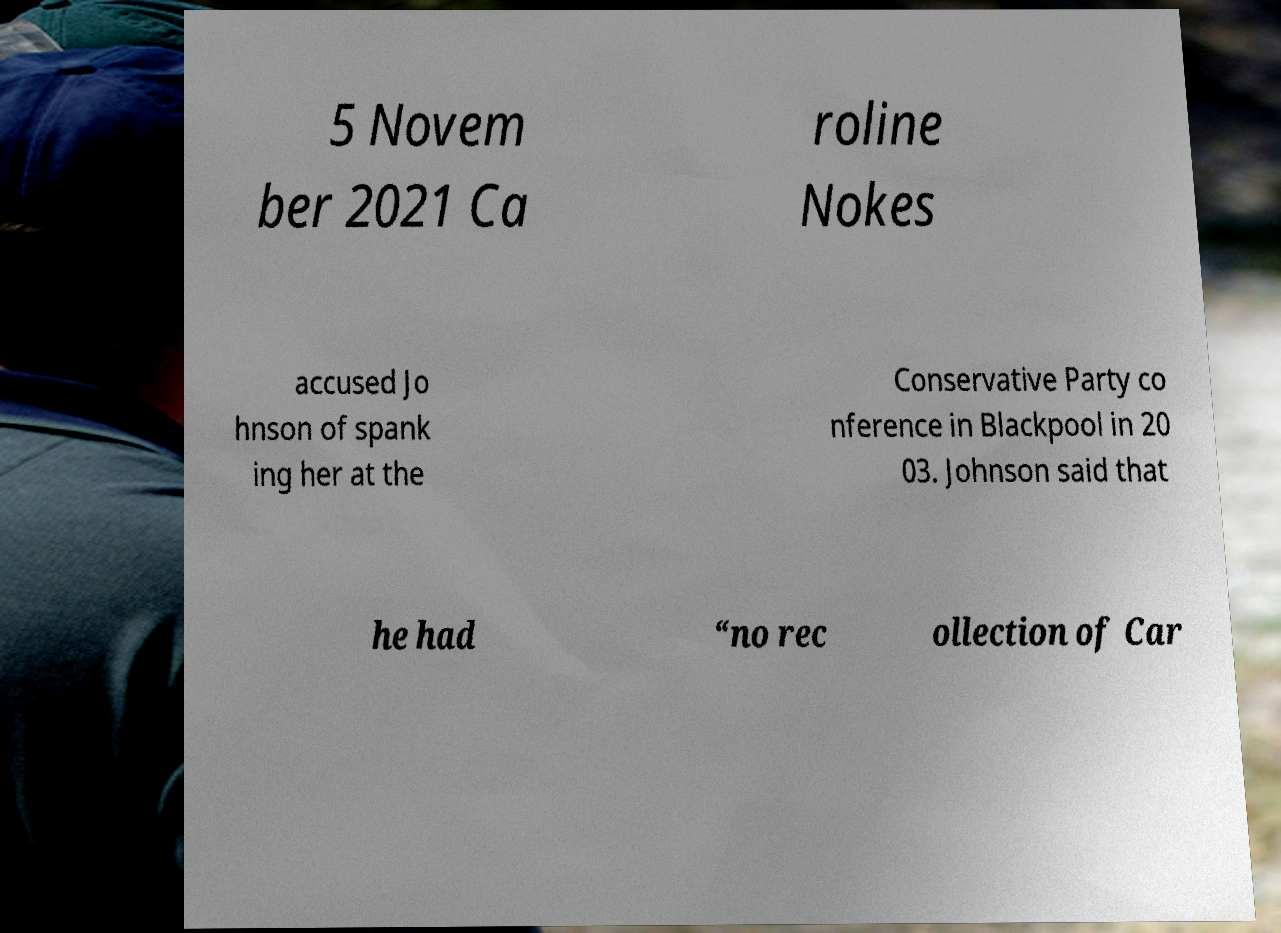Can you read and provide the text displayed in the image?This photo seems to have some interesting text. Can you extract and type it out for me? 5 Novem ber 2021 Ca roline Nokes accused Jo hnson of spank ing her at the Conservative Party co nference in Blackpool in 20 03. Johnson said that he had “no rec ollection of Car 